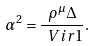<formula> <loc_0><loc_0><loc_500><loc_500>\alpha ^ { 2 } = \frac { \rho ^ { \mu } \Delta } { \ V i r 1 } .</formula> 